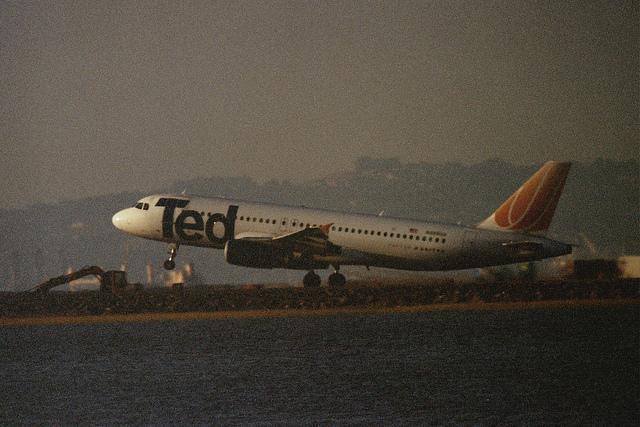How many wheels does the plane have?
Give a very brief answer. 3. How many letter D are on the plane?
Give a very brief answer. 1. 